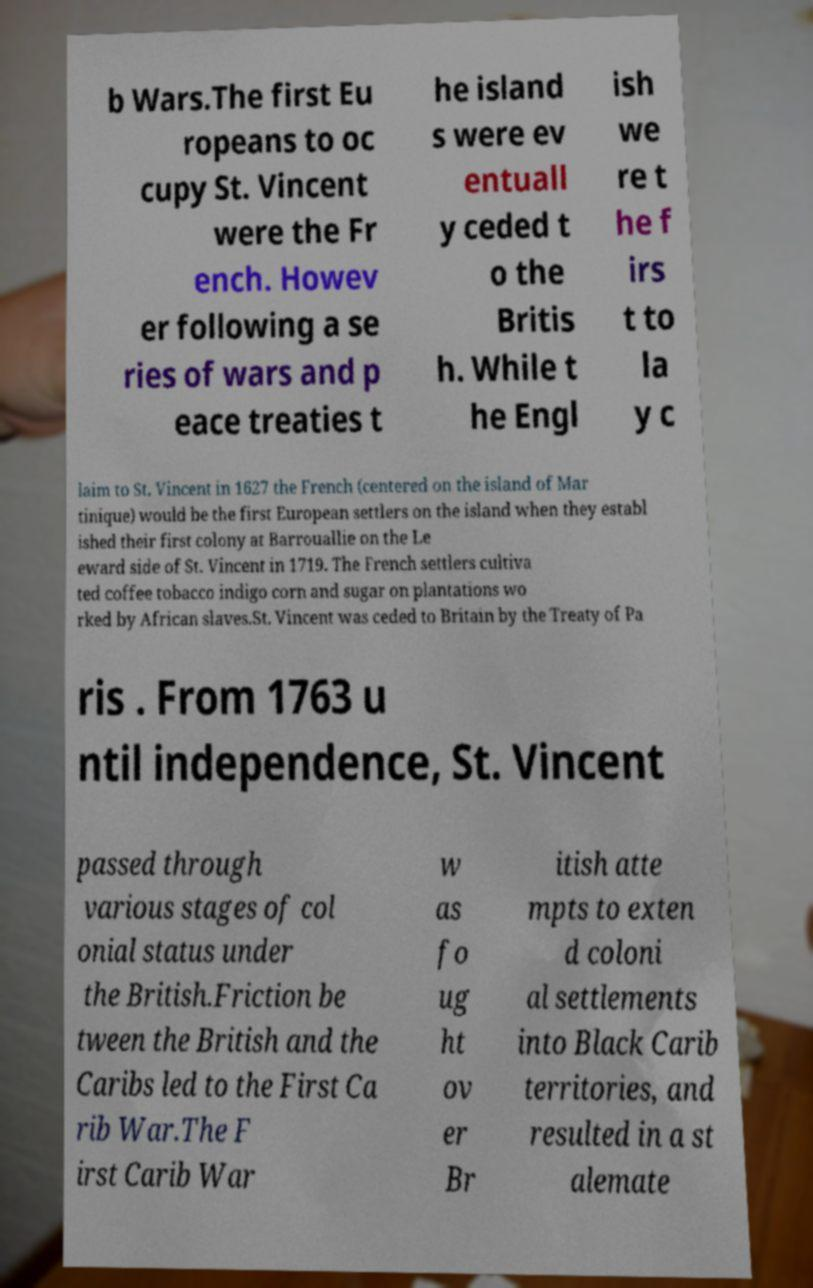Please identify and transcribe the text found in this image. b Wars.The first Eu ropeans to oc cupy St. Vincent were the Fr ench. Howev er following a se ries of wars and p eace treaties t he island s were ev entuall y ceded t o the Britis h. While t he Engl ish we re t he f irs t to la y c laim to St. Vincent in 1627 the French (centered on the island of Mar tinique) would be the first European settlers on the island when they establ ished their first colony at Barrouallie on the Le eward side of St. Vincent in 1719. The French settlers cultiva ted coffee tobacco indigo corn and sugar on plantations wo rked by African slaves.St. Vincent was ceded to Britain by the Treaty of Pa ris . From 1763 u ntil independence, St. Vincent passed through various stages of col onial status under the British.Friction be tween the British and the Caribs led to the First Ca rib War.The F irst Carib War w as fo ug ht ov er Br itish atte mpts to exten d coloni al settlements into Black Carib territories, and resulted in a st alemate 